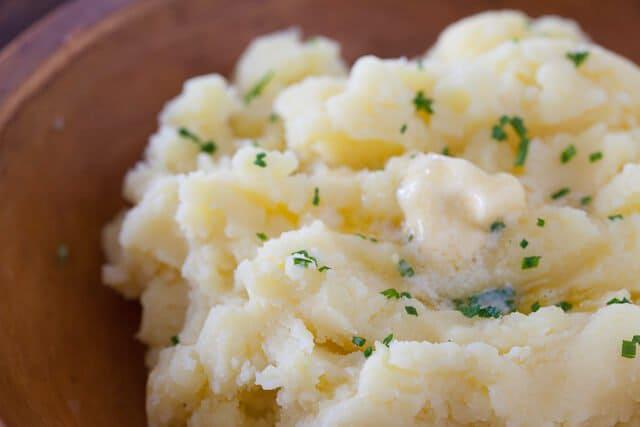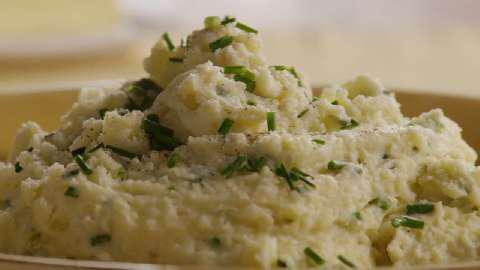The first image is the image on the left, the second image is the image on the right. Analyze the images presented: Is the assertion "One of the mashed potato dishes does not contain chives." valid? Answer yes or no. No. The first image is the image on the left, the second image is the image on the right. Examine the images to the left and right. Is the description "The food in the image on the left is sitting in a brown plate." accurate? Answer yes or no. Yes. 